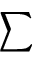<formula> <loc_0><loc_0><loc_500><loc_500>\sum</formula> 